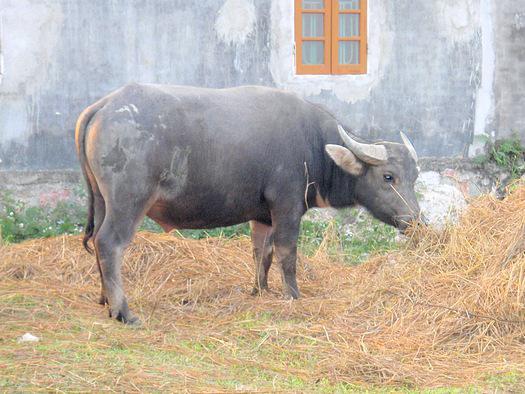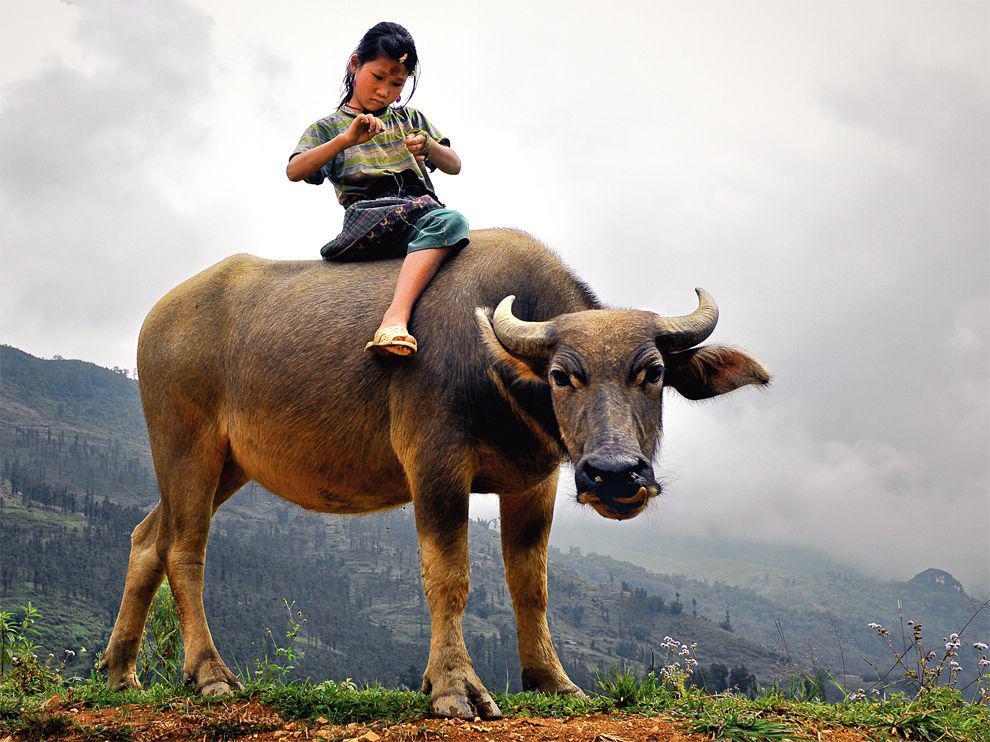The first image is the image on the left, the second image is the image on the right. Analyze the images presented: Is the assertion "The combined images include multiple people wearing hats, multiple water buffalos, and at least one person wearing a hat while on top of a water buffalo." valid? Answer yes or no. No. The first image is the image on the left, the second image is the image on the right. Analyze the images presented: Is the assertion "There is exactly one person sitting on an animal." valid? Answer yes or no. Yes. 